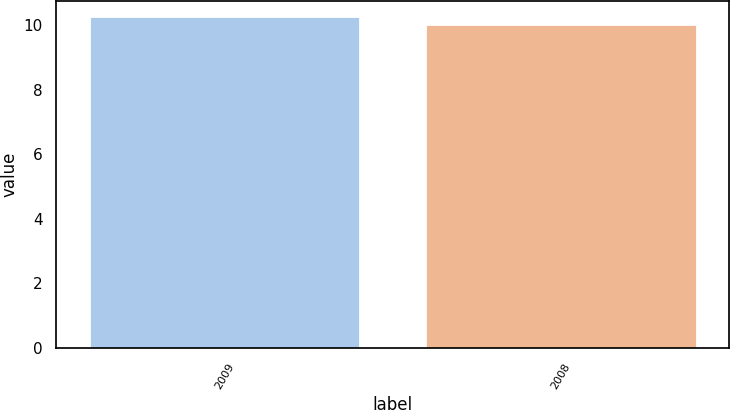<chart> <loc_0><loc_0><loc_500><loc_500><bar_chart><fcel>2009<fcel>2008<nl><fcel>10.25<fcel>10<nl></chart> 